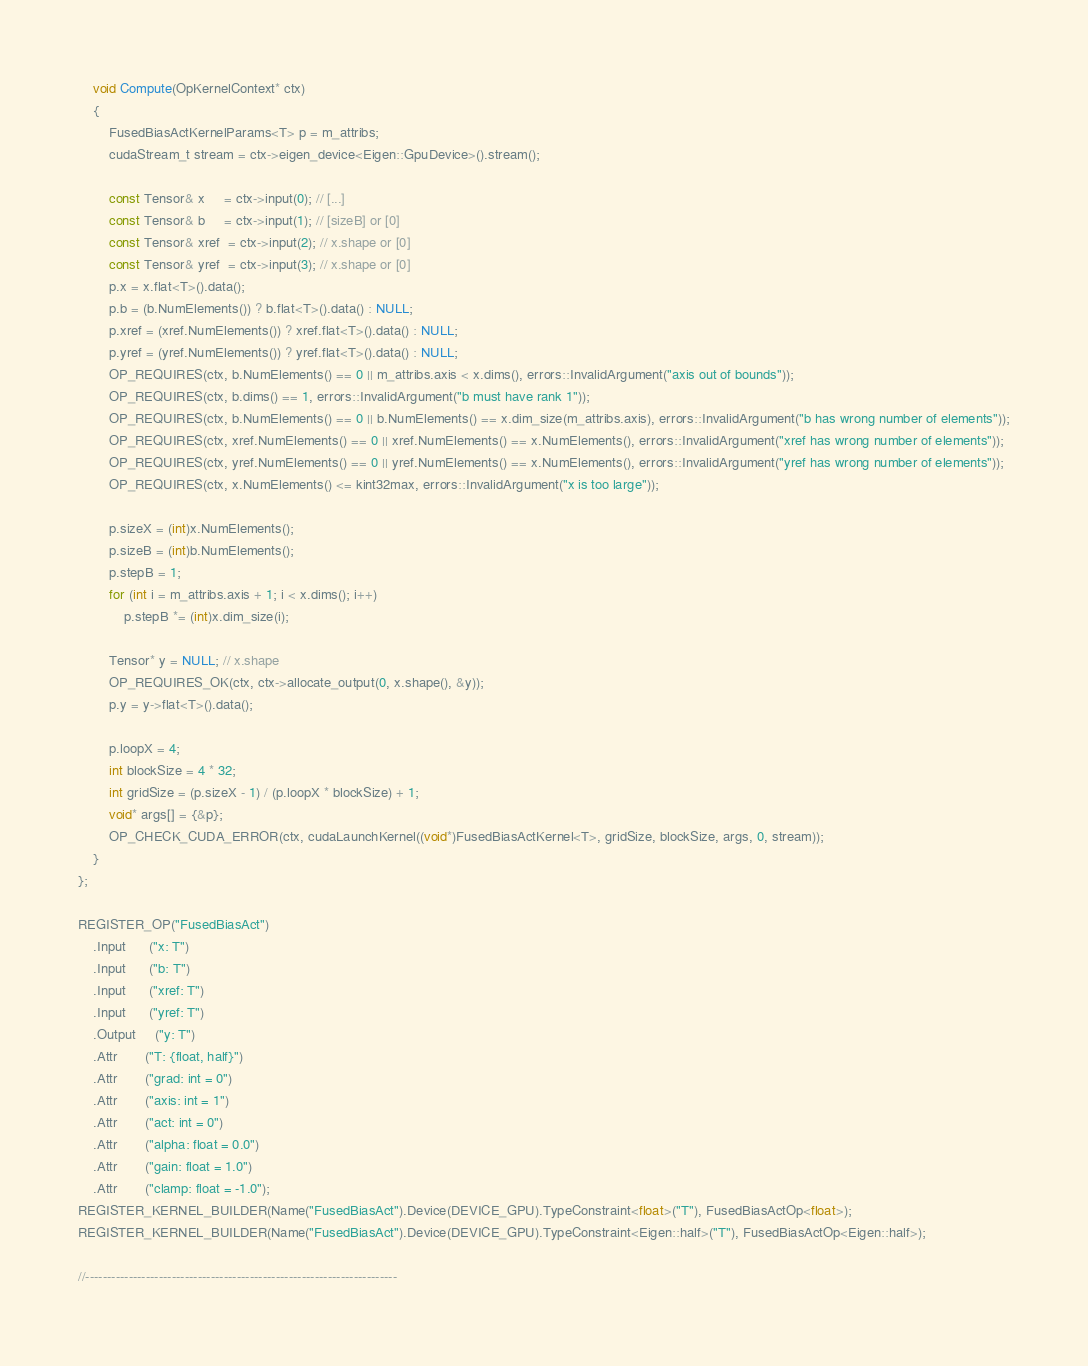Convert code to text. <code><loc_0><loc_0><loc_500><loc_500><_Cuda_>    void Compute(OpKernelContext* ctx)
    {
        FusedBiasActKernelParams<T> p = m_attribs;
        cudaStream_t stream = ctx->eigen_device<Eigen::GpuDevice>().stream();

        const Tensor& x     = ctx->input(0); // [...]
        const Tensor& b     = ctx->input(1); // [sizeB] or [0]
        const Tensor& xref  = ctx->input(2); // x.shape or [0]
        const Tensor& yref  = ctx->input(3); // x.shape or [0]
        p.x = x.flat<T>().data();
        p.b = (b.NumElements()) ? b.flat<T>().data() : NULL;
        p.xref = (xref.NumElements()) ? xref.flat<T>().data() : NULL;
        p.yref = (yref.NumElements()) ? yref.flat<T>().data() : NULL;
        OP_REQUIRES(ctx, b.NumElements() == 0 || m_attribs.axis < x.dims(), errors::InvalidArgument("axis out of bounds"));
        OP_REQUIRES(ctx, b.dims() == 1, errors::InvalidArgument("b must have rank 1"));
        OP_REQUIRES(ctx, b.NumElements() == 0 || b.NumElements() == x.dim_size(m_attribs.axis), errors::InvalidArgument("b has wrong number of elements"));
        OP_REQUIRES(ctx, xref.NumElements() == 0 || xref.NumElements() == x.NumElements(), errors::InvalidArgument("xref has wrong number of elements"));
        OP_REQUIRES(ctx, yref.NumElements() == 0 || yref.NumElements() == x.NumElements(), errors::InvalidArgument("yref has wrong number of elements"));
        OP_REQUIRES(ctx, x.NumElements() <= kint32max, errors::InvalidArgument("x is too large"));

        p.sizeX = (int)x.NumElements();
        p.sizeB = (int)b.NumElements();
        p.stepB = 1;
        for (int i = m_attribs.axis + 1; i < x.dims(); i++)
            p.stepB *= (int)x.dim_size(i);

        Tensor* y = NULL; // x.shape
        OP_REQUIRES_OK(ctx, ctx->allocate_output(0, x.shape(), &y));
        p.y = y->flat<T>().data();

        p.loopX = 4;
        int blockSize = 4 * 32;
        int gridSize = (p.sizeX - 1) / (p.loopX * blockSize) + 1;
        void* args[] = {&p};
        OP_CHECK_CUDA_ERROR(ctx, cudaLaunchKernel((void*)FusedBiasActKernel<T>, gridSize, blockSize, args, 0, stream));
    }
};

REGISTER_OP("FusedBiasAct")
    .Input      ("x: T")
    .Input      ("b: T")
    .Input      ("xref: T")
    .Input      ("yref: T")
    .Output     ("y: T")
    .Attr       ("T: {float, half}")
    .Attr       ("grad: int = 0")
    .Attr       ("axis: int = 1")
    .Attr       ("act: int = 0")
    .Attr       ("alpha: float = 0.0")
    .Attr       ("gain: float = 1.0")
    .Attr       ("clamp: float = -1.0");
REGISTER_KERNEL_BUILDER(Name("FusedBiasAct").Device(DEVICE_GPU).TypeConstraint<float>("T"), FusedBiasActOp<float>);
REGISTER_KERNEL_BUILDER(Name("FusedBiasAct").Device(DEVICE_GPU).TypeConstraint<Eigen::half>("T"), FusedBiasActOp<Eigen::half>);

//------------------------------------------------------------------------
</code> 